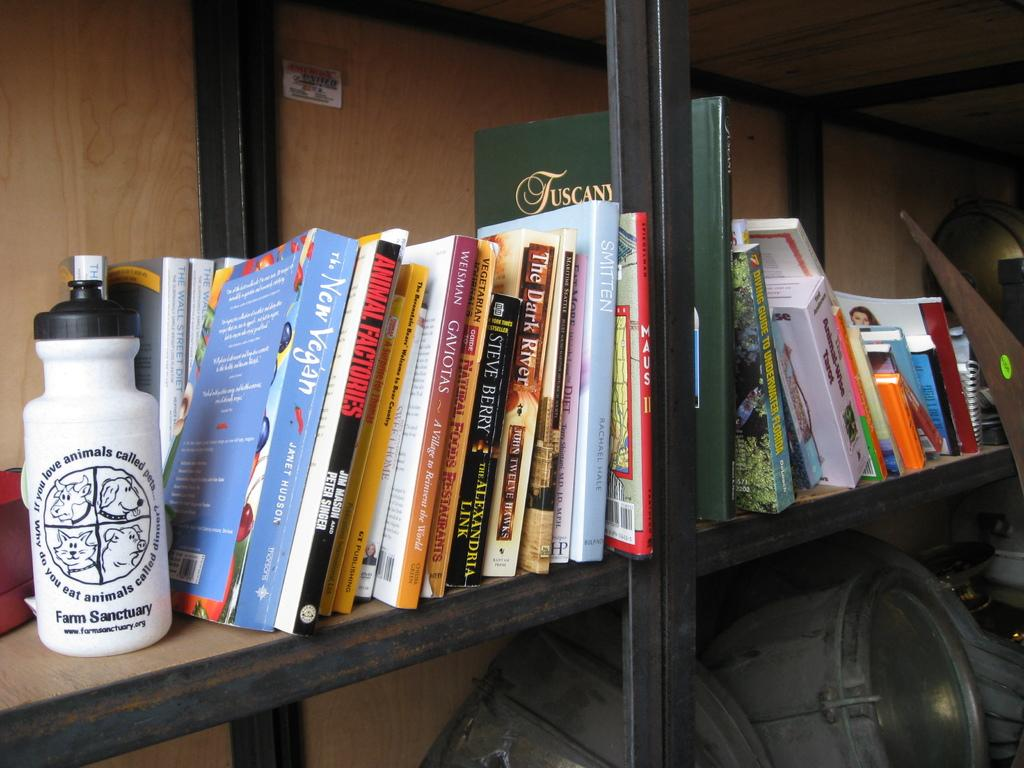<image>
Offer a succinct explanation of the picture presented. Shelf full of books and one title is Animal Factories. 